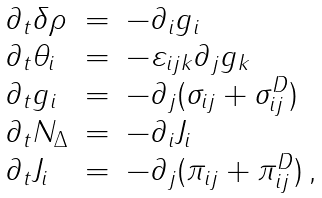Convert formula to latex. <formula><loc_0><loc_0><loc_500><loc_500>\begin{array} { l c l } \partial _ { t } \delta \rho & = & - \partial _ { i } g _ { i } \\ \partial _ { t } \theta _ { i } & = & - \varepsilon _ { i j k } \partial _ { j } g _ { k } \\ \partial _ { t } g _ { i } & = & - \partial _ { j } ( \sigma _ { i j } + \sigma _ { i j } ^ { D } ) \\ \partial _ { t } N _ { \Delta } & = & - \partial _ { i } J _ { i } \\ \partial _ { t } J _ { i } & = & - \partial _ { j } ( \pi _ { i j } + \pi _ { i j } ^ { D } ) \, , \end{array}</formula> 